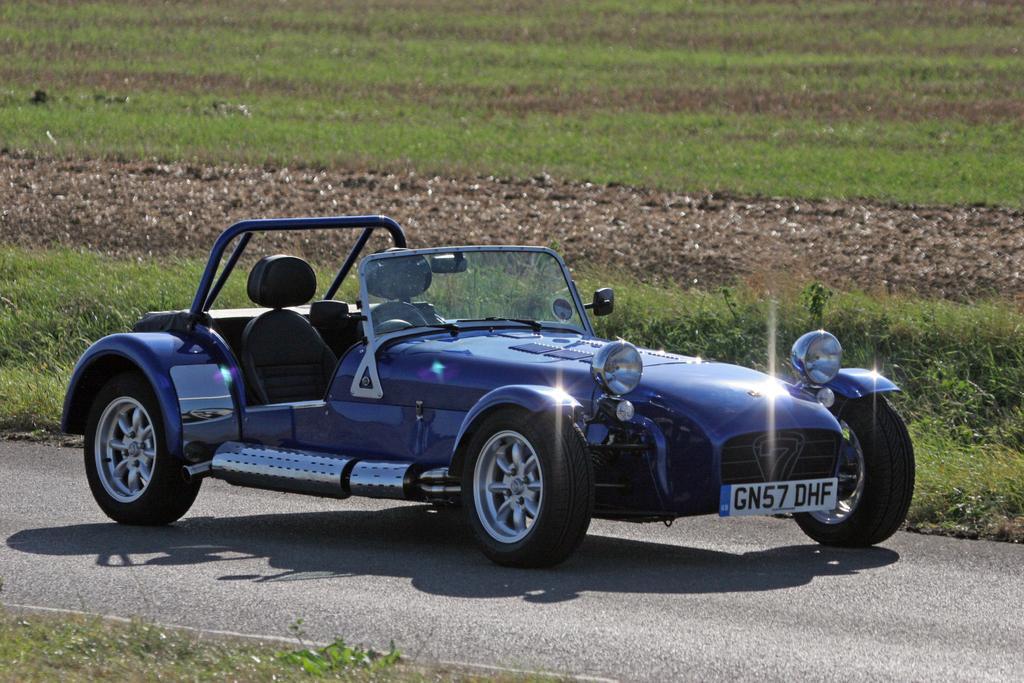Describe this image in one or two sentences. In this image I can see a road and on it I can see a shadow and a blue colour vehicle. I can also see something is written over here and in the background I can see an open grass ground. 